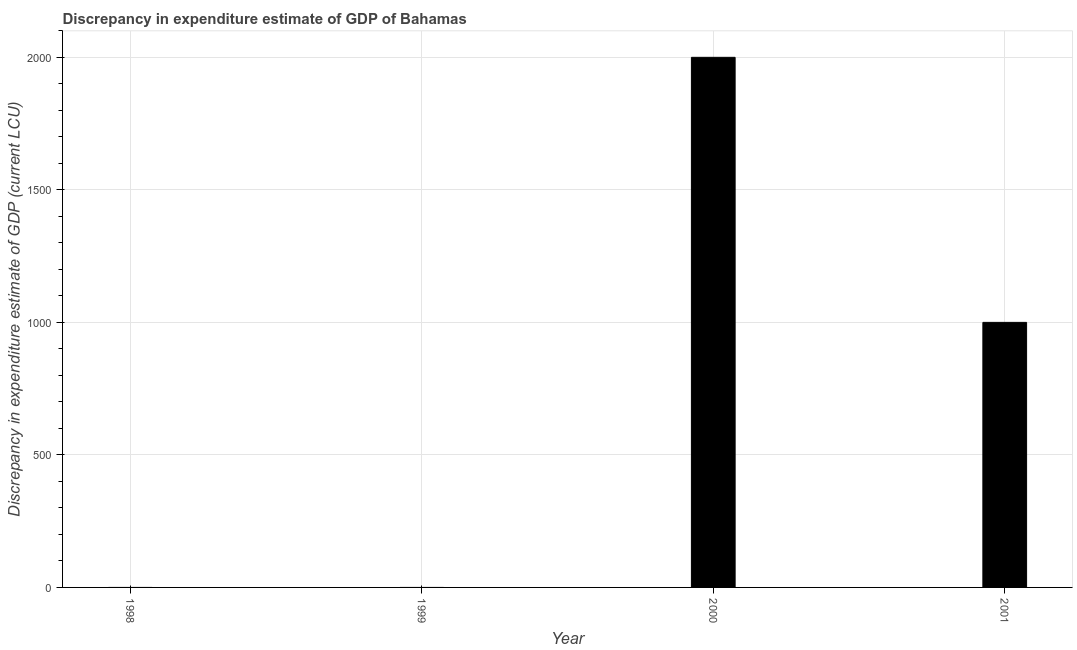Does the graph contain grids?
Provide a succinct answer. Yes. What is the title of the graph?
Your answer should be very brief. Discrepancy in expenditure estimate of GDP of Bahamas. What is the label or title of the X-axis?
Make the answer very short. Year. What is the label or title of the Y-axis?
Ensure brevity in your answer.  Discrepancy in expenditure estimate of GDP (current LCU). What is the discrepancy in expenditure estimate of gdp in 1998?
Ensure brevity in your answer.  0. What is the sum of the discrepancy in expenditure estimate of gdp?
Your answer should be very brief. 3000. What is the difference between the discrepancy in expenditure estimate of gdp in 2000 and 2001?
Offer a terse response. 1000. What is the average discrepancy in expenditure estimate of gdp per year?
Provide a short and direct response. 750. What is the median discrepancy in expenditure estimate of gdp?
Provide a short and direct response. 500. In how many years, is the discrepancy in expenditure estimate of gdp greater than 600 LCU?
Keep it short and to the point. 2. Are all the bars in the graph horizontal?
Provide a short and direct response. No. What is the Discrepancy in expenditure estimate of GDP (current LCU) in 1998?
Offer a terse response. 0. What is the Discrepancy in expenditure estimate of GDP (current LCU) of 2000?
Offer a very short reply. 2000. What is the Discrepancy in expenditure estimate of GDP (current LCU) in 2001?
Give a very brief answer. 1000. What is the difference between the Discrepancy in expenditure estimate of GDP (current LCU) in 2000 and 2001?
Ensure brevity in your answer.  1000. What is the ratio of the Discrepancy in expenditure estimate of GDP (current LCU) in 2000 to that in 2001?
Your response must be concise. 2. 